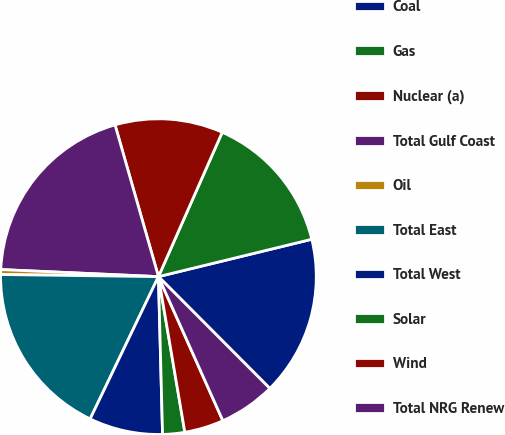<chart> <loc_0><loc_0><loc_500><loc_500><pie_chart><fcel>Coal<fcel>Gas<fcel>Nuclear (a)<fcel>Total Gulf Coast<fcel>Oil<fcel>Total East<fcel>Total West<fcel>Solar<fcel>Wind<fcel>Total NRG Renew<nl><fcel>16.34%<fcel>14.58%<fcel>11.06%<fcel>19.86%<fcel>0.5%<fcel>18.1%<fcel>7.54%<fcel>2.26%<fcel>4.02%<fcel>5.78%<nl></chart> 